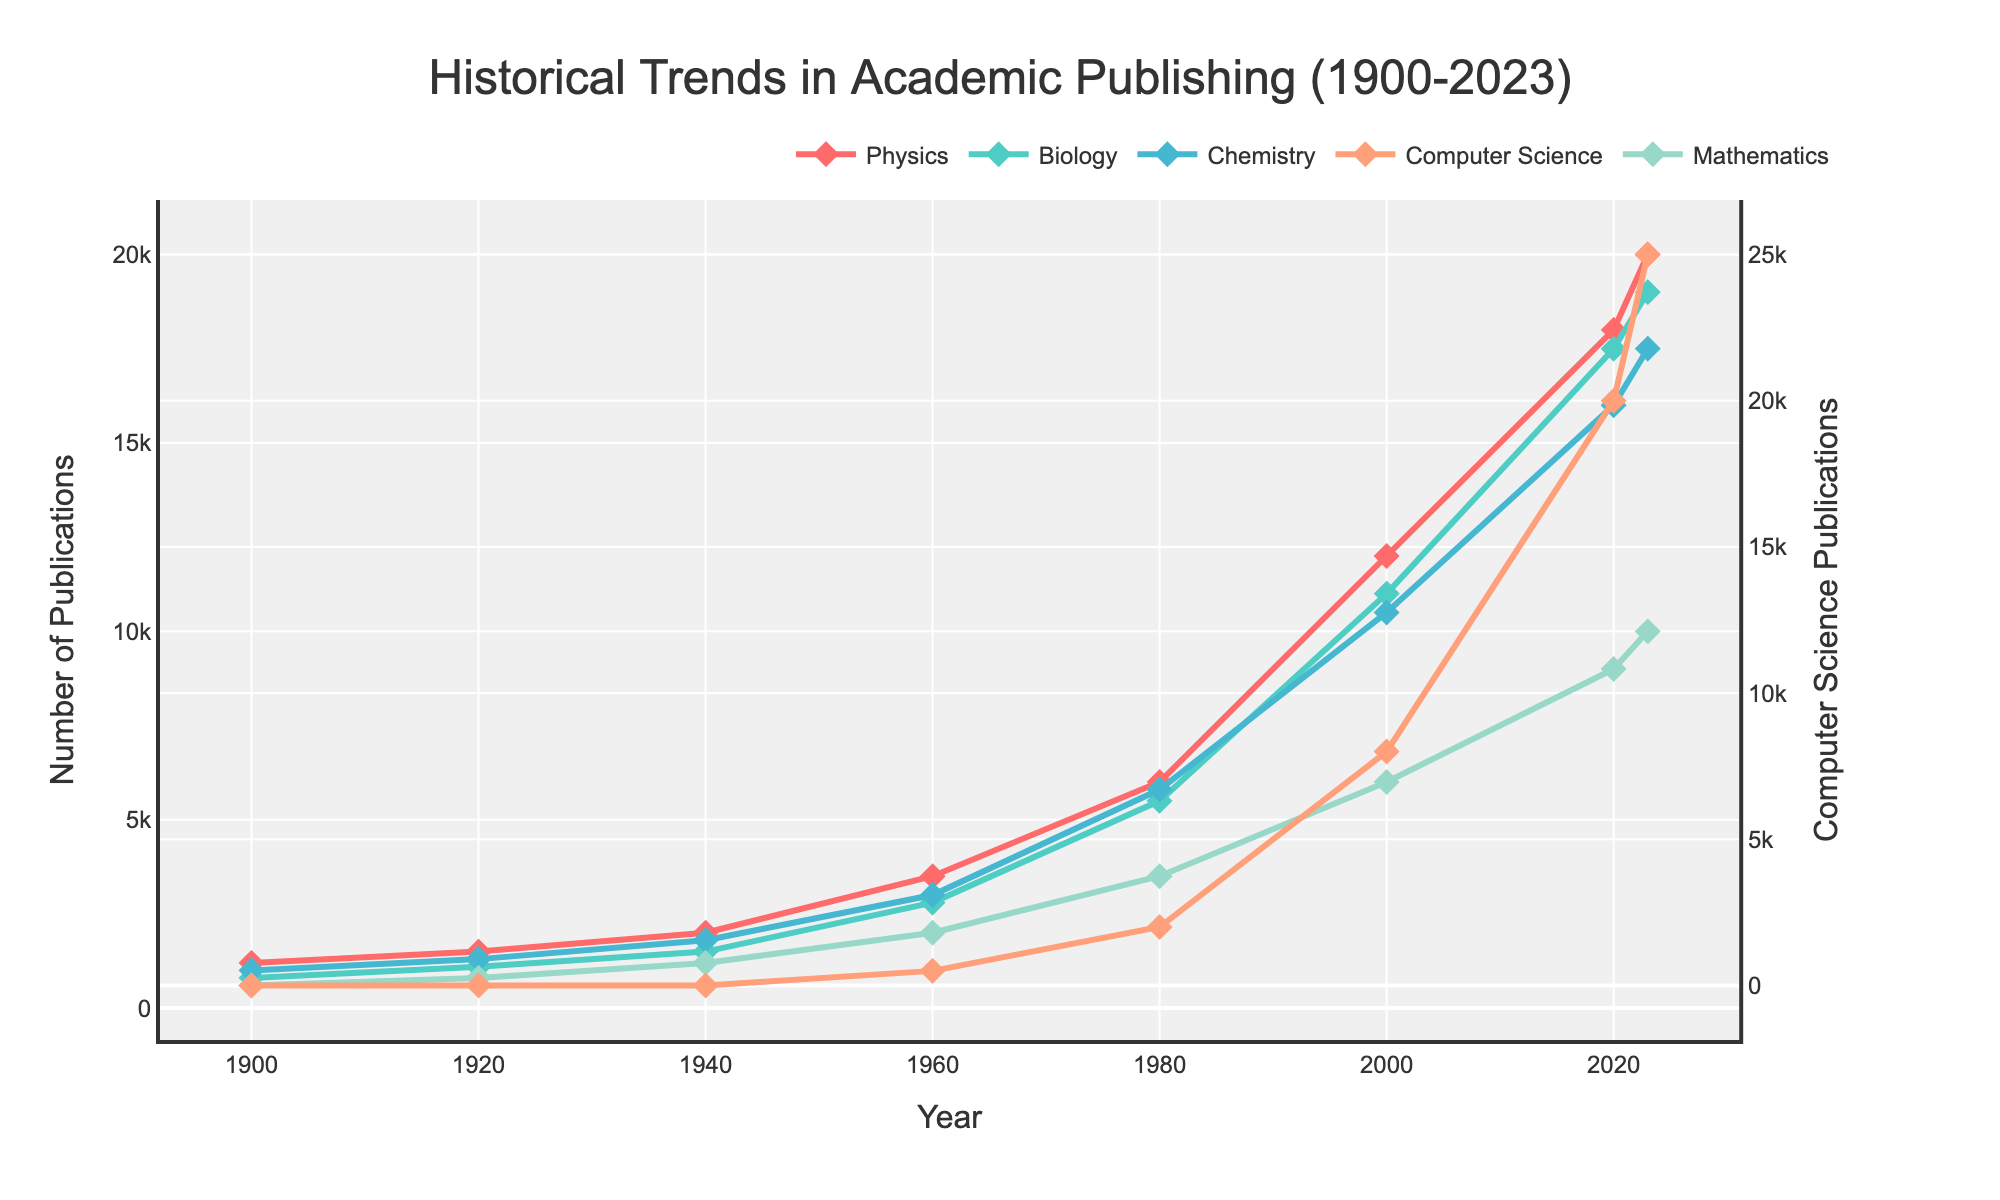What is the trend in Computer Science publications between 2000 and 2023? From the figure, observe the Computer Science line, which shows an increasing trend from 8000 publications in 2000 to 25000 publications in 2023.
Answer: Increasing Which discipline had the highest number of publications in 2023? In the figure for the year 2023, it shows that Computer Science had the highest number of publications, indicated by the line reaching approximately 25000.
Answer: Computer Science Compare the publication trends in Physics and Biology from 1960 to 2020. Which discipline showed more growth? Observe the Physics and Biology lines from 1960 to 2020. Physics grew from 3500 to 18000 publications, while Biology grew from 2800 to 17500. Therefore, Physics showed more growth.
Answer: Physics What is the difference in the number of publications between Chemistry and Mathematics in 1980? The number of publications for Chemistry in 1980 is 5800, while for Mathematics it is 3500. The difference is 5800 - 3500 = 2300.
Answer: 2300 During which period did Biology publications increase the most? By following the Biology line on the figure, the steepest increase appears between 1960 and 1980, where it goes from 2800 to 5500, constituting a significant growth.
Answer: 1960 to 1980 Calculate the average number of publications in Chemistry between 1900 and 2023. Add the number of Chemistry publications across the years (1000 + 1300 + 1800 + 3000 + 5800 + 10500 + 16000 + 17500) and divide by 8. That is (1000 + 1300 + 1800 + 3000 + 5800 + 10500 + 16000 + 17500) / 8 = 7262.5.
Answer: 7262.5 Which discipline had the steepest growth between 2000 and 2023? By observing the slopes of each line during this period, Computer Science increased from 8000 to 25000, which indicates the steepest growth.
Answer: Computer Science What is the relative position (highest, lowest, in-between) of Mathematics publications compared to the other disciplines in 1960? In 1960, by observing all the lines, Mathematics publications stand lower than Physics, Chemistry, and Biology but above Computer Science which had 0 publications.
Answer: In-between What visual attribute distinguishes the Computer Science trend line in the figure? The Computer Science trend line is distinguished by its color, which is noticeably different (likely a visually distinct shade) from the other disciplines and markers in the figure.
Answer: Color Is there any overlap in the number of publications between Biology and Physics during 1920 and 1940? In the figure, compare the Biology and Physics lines between 1920 and 1940. The lines do not overlap; Physics always has more publications than Biology during this period.
Answer: No 